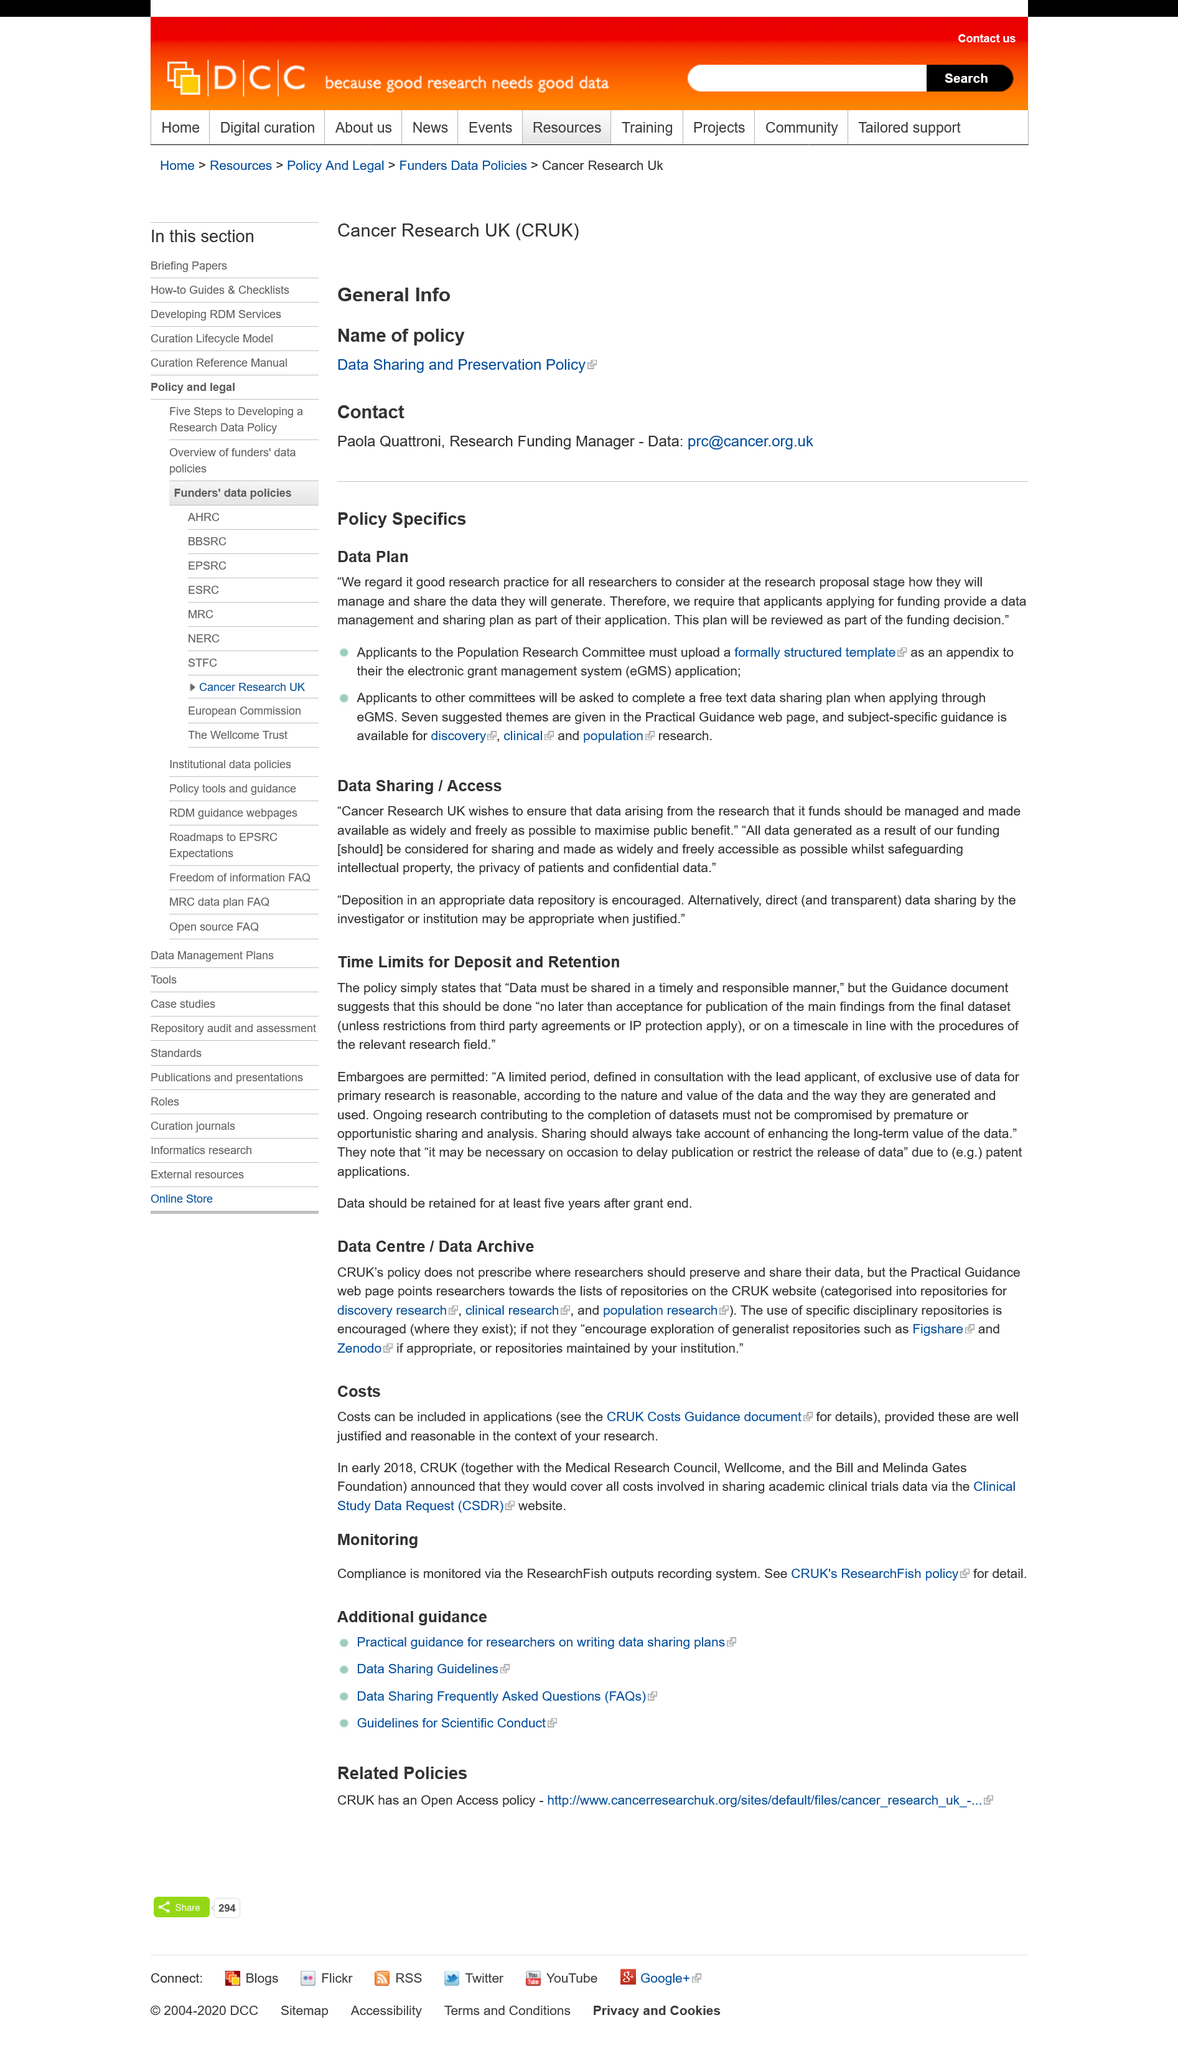Give some essential details in this illustration. Compliance with the Researchfish outputs recording system is monitored to ensure adherence to the requirements. This page is reviewing the policy of a named organization, which is the Cancer Research UK policy. Yes, subject-specific guidance is available for discovery, clinical, and population research. It is provided that an example is given when it may be necessary to delay publication or restrict the release of data, and that such a situation occurs in the context of patent applications. The information on costing can be obtained from the CRUK Costs Guidance documents, which provide further details on the subject. 